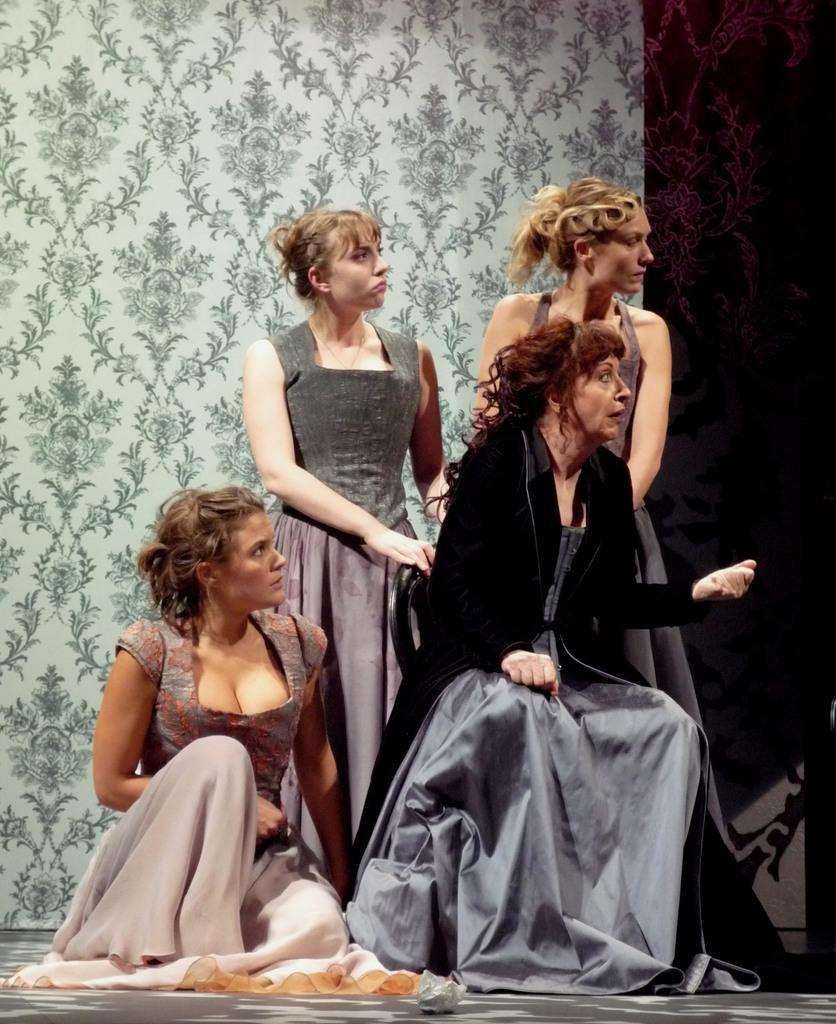How many women are present in the image? There are four women in the image. What are the positions of the women in the image? Two of the women are sitting, and the remaining two women are standing. Which direction are the women looking? All the women are looking to the right side. What can be seen in the background of the image? There is a wall in the background of the image. What type of rose can be seen growing on the playground in the image? There is no playground or rose present in the image. How are the women transported to the location in the image? The image does not provide information about how the women arrived at the location. 